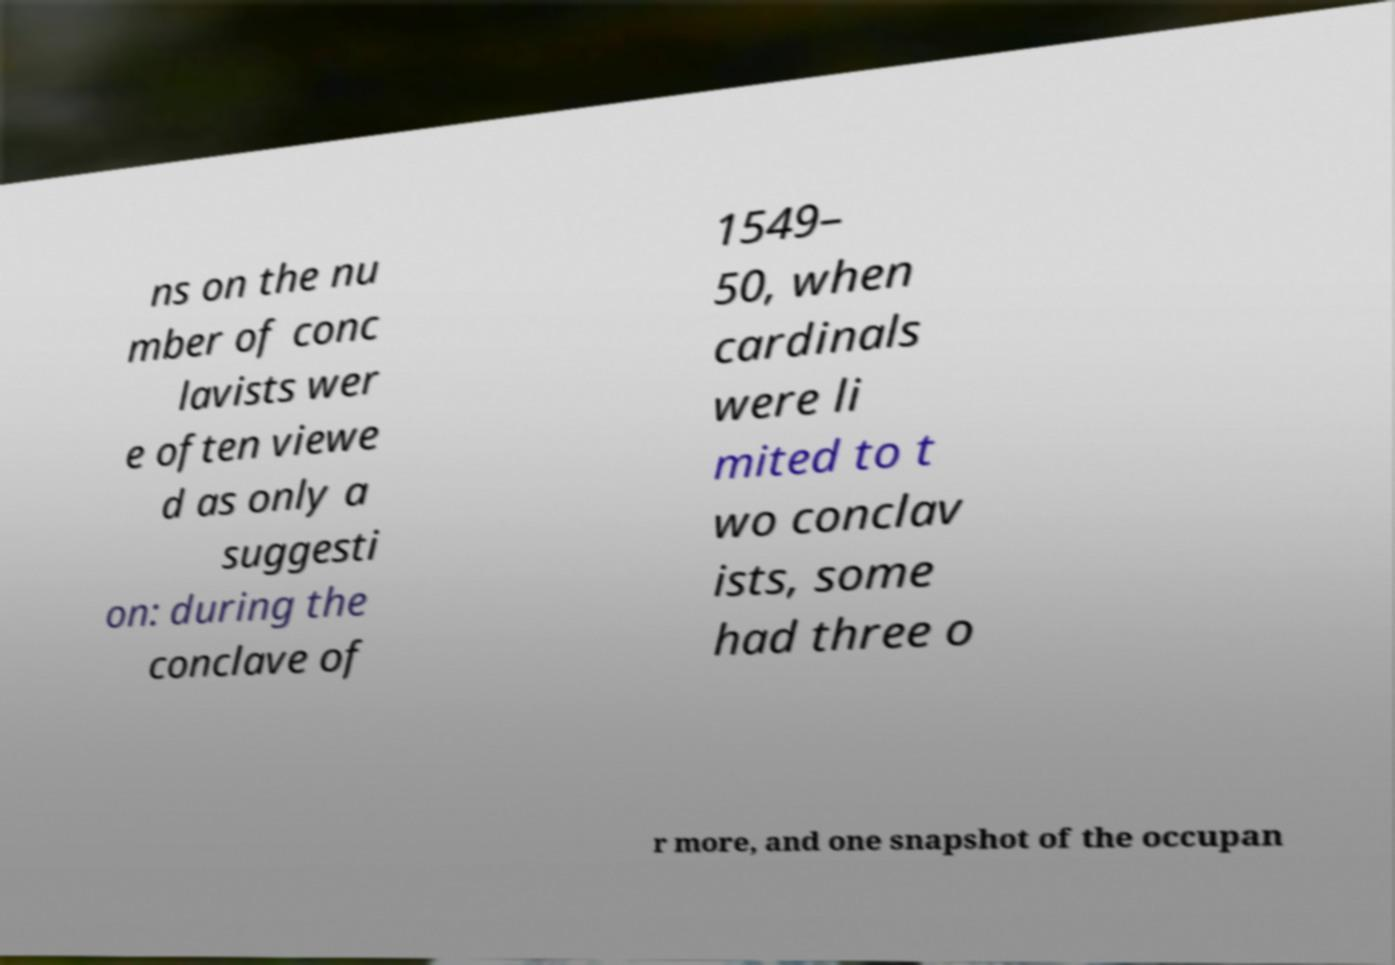There's text embedded in this image that I need extracted. Can you transcribe it verbatim? ns on the nu mber of conc lavists wer e often viewe d as only a suggesti on: during the conclave of 1549– 50, when cardinals were li mited to t wo conclav ists, some had three o r more, and one snapshot of the occupan 